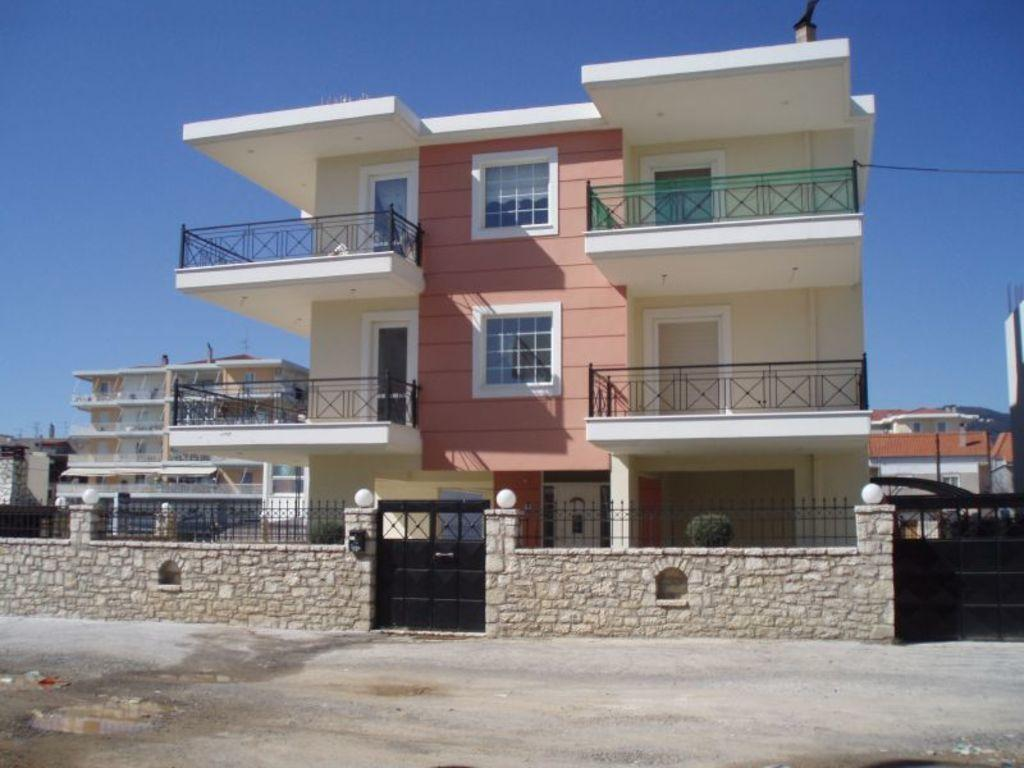What type of structures can be seen in the image? There are buildings in the image. What is visible at the top of the image? The sky is visible at the top of the image. What type of entrance is present in the image? There are gates in the image. What type of barrier is present in the image? A stone wall and a fencing panel are present in the image. What type of illumination is visible in the image? Lights are visible in the image. What type of vegetation is present in the image? There is a plant in the image. Can you see any wings on the buildings in the image? There are no wings visible on the buildings in the image. What type of bean is growing on the plant in the image? There is no bean growing on the plant in the image; it is not a bean plant. 